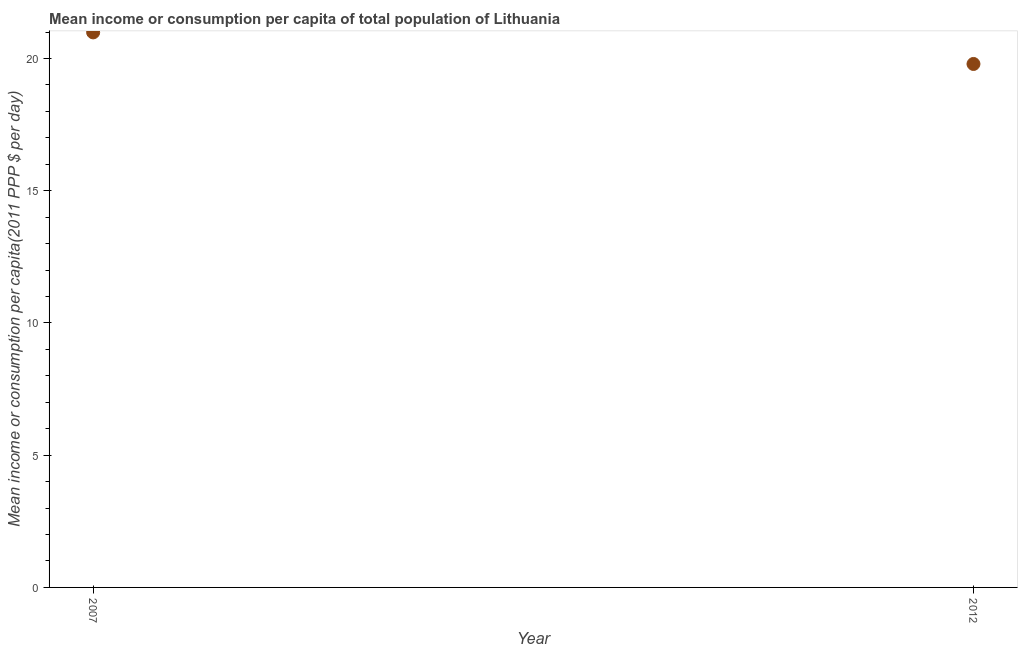What is the mean income or consumption in 2012?
Keep it short and to the point. 19.79. Across all years, what is the maximum mean income or consumption?
Offer a very short reply. 20.99. Across all years, what is the minimum mean income or consumption?
Ensure brevity in your answer.  19.79. In which year was the mean income or consumption maximum?
Offer a terse response. 2007. In which year was the mean income or consumption minimum?
Your answer should be compact. 2012. What is the sum of the mean income or consumption?
Provide a short and direct response. 40.78. What is the difference between the mean income or consumption in 2007 and 2012?
Provide a succinct answer. 1.19. What is the average mean income or consumption per year?
Your answer should be compact. 20.39. What is the median mean income or consumption?
Make the answer very short. 20.39. In how many years, is the mean income or consumption greater than 8 $?
Your answer should be very brief. 2. What is the ratio of the mean income or consumption in 2007 to that in 2012?
Provide a short and direct response. 1.06. In how many years, is the mean income or consumption greater than the average mean income or consumption taken over all years?
Keep it short and to the point. 1. What is the difference between two consecutive major ticks on the Y-axis?
Your response must be concise. 5. Are the values on the major ticks of Y-axis written in scientific E-notation?
Your answer should be very brief. No. Does the graph contain grids?
Your response must be concise. No. What is the title of the graph?
Provide a short and direct response. Mean income or consumption per capita of total population of Lithuania. What is the label or title of the X-axis?
Provide a short and direct response. Year. What is the label or title of the Y-axis?
Give a very brief answer. Mean income or consumption per capita(2011 PPP $ per day). What is the Mean income or consumption per capita(2011 PPP $ per day) in 2007?
Provide a short and direct response. 20.99. What is the Mean income or consumption per capita(2011 PPP $ per day) in 2012?
Offer a very short reply. 19.79. What is the difference between the Mean income or consumption per capita(2011 PPP $ per day) in 2007 and 2012?
Provide a succinct answer. 1.19. What is the ratio of the Mean income or consumption per capita(2011 PPP $ per day) in 2007 to that in 2012?
Make the answer very short. 1.06. 